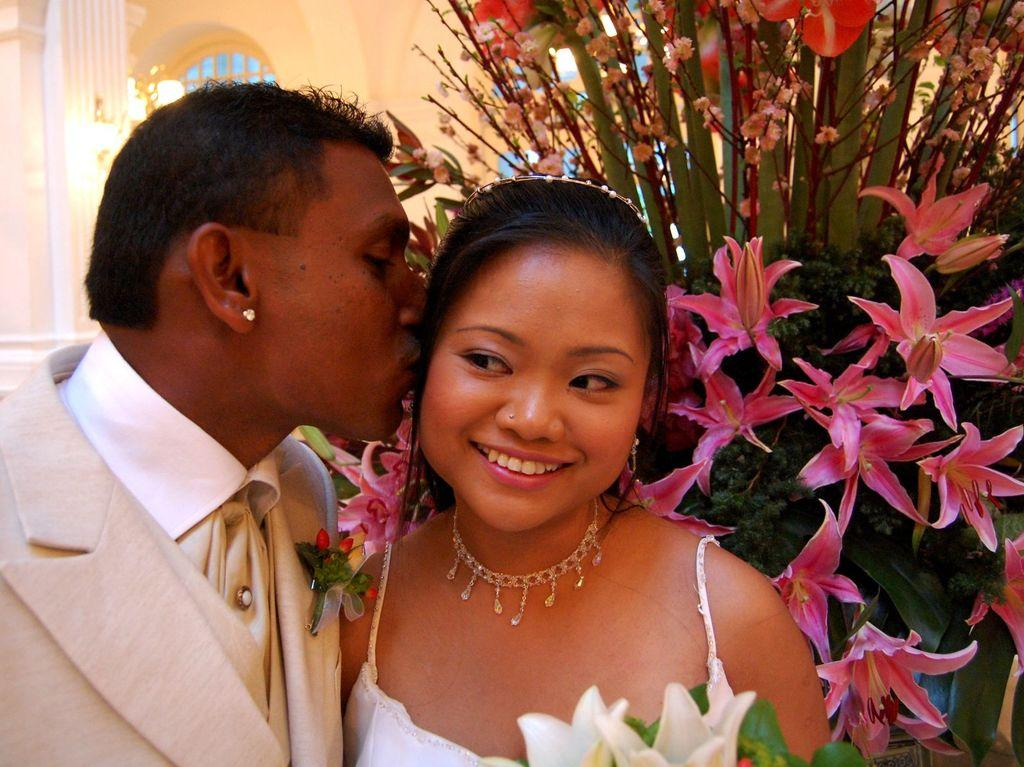How many people are present in the image? There are two people standing in the image. What can be observed about the people's clothing? The people are wearing different color dresses. What types of flowers can be seen in the image? There are pink, white, and red color flowers in the image. What is visible in the background of the image? There is a cream-colored building and a window visible in the background. What is the name of the church in the image? There is no church present in the image; it features a cream-colored building in the background. What message of hope can be seen in the image? There is no message of hope visible in the image; it primarily focuses on the two people and the flowers. 